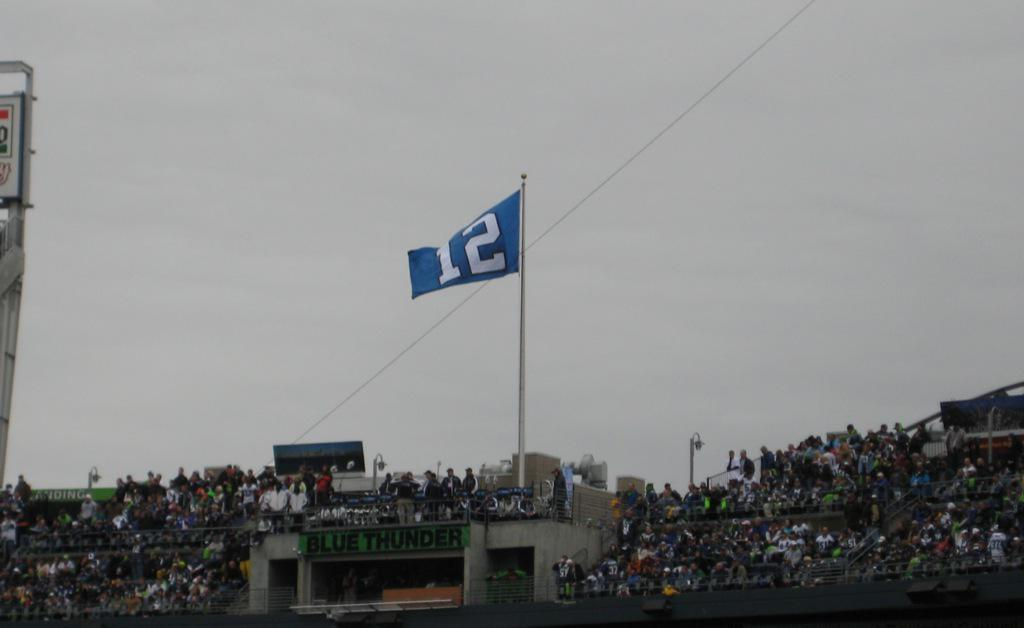<image>
Offer a succinct explanation of the picture presented. A blue flag rising above a stadium with a white number 12 on it. 